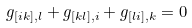<formula> <loc_0><loc_0><loc_500><loc_500>g _ { [ i k ] , l } + g _ { [ k l ] , i } + g _ { [ l i ] , k } = 0</formula> 